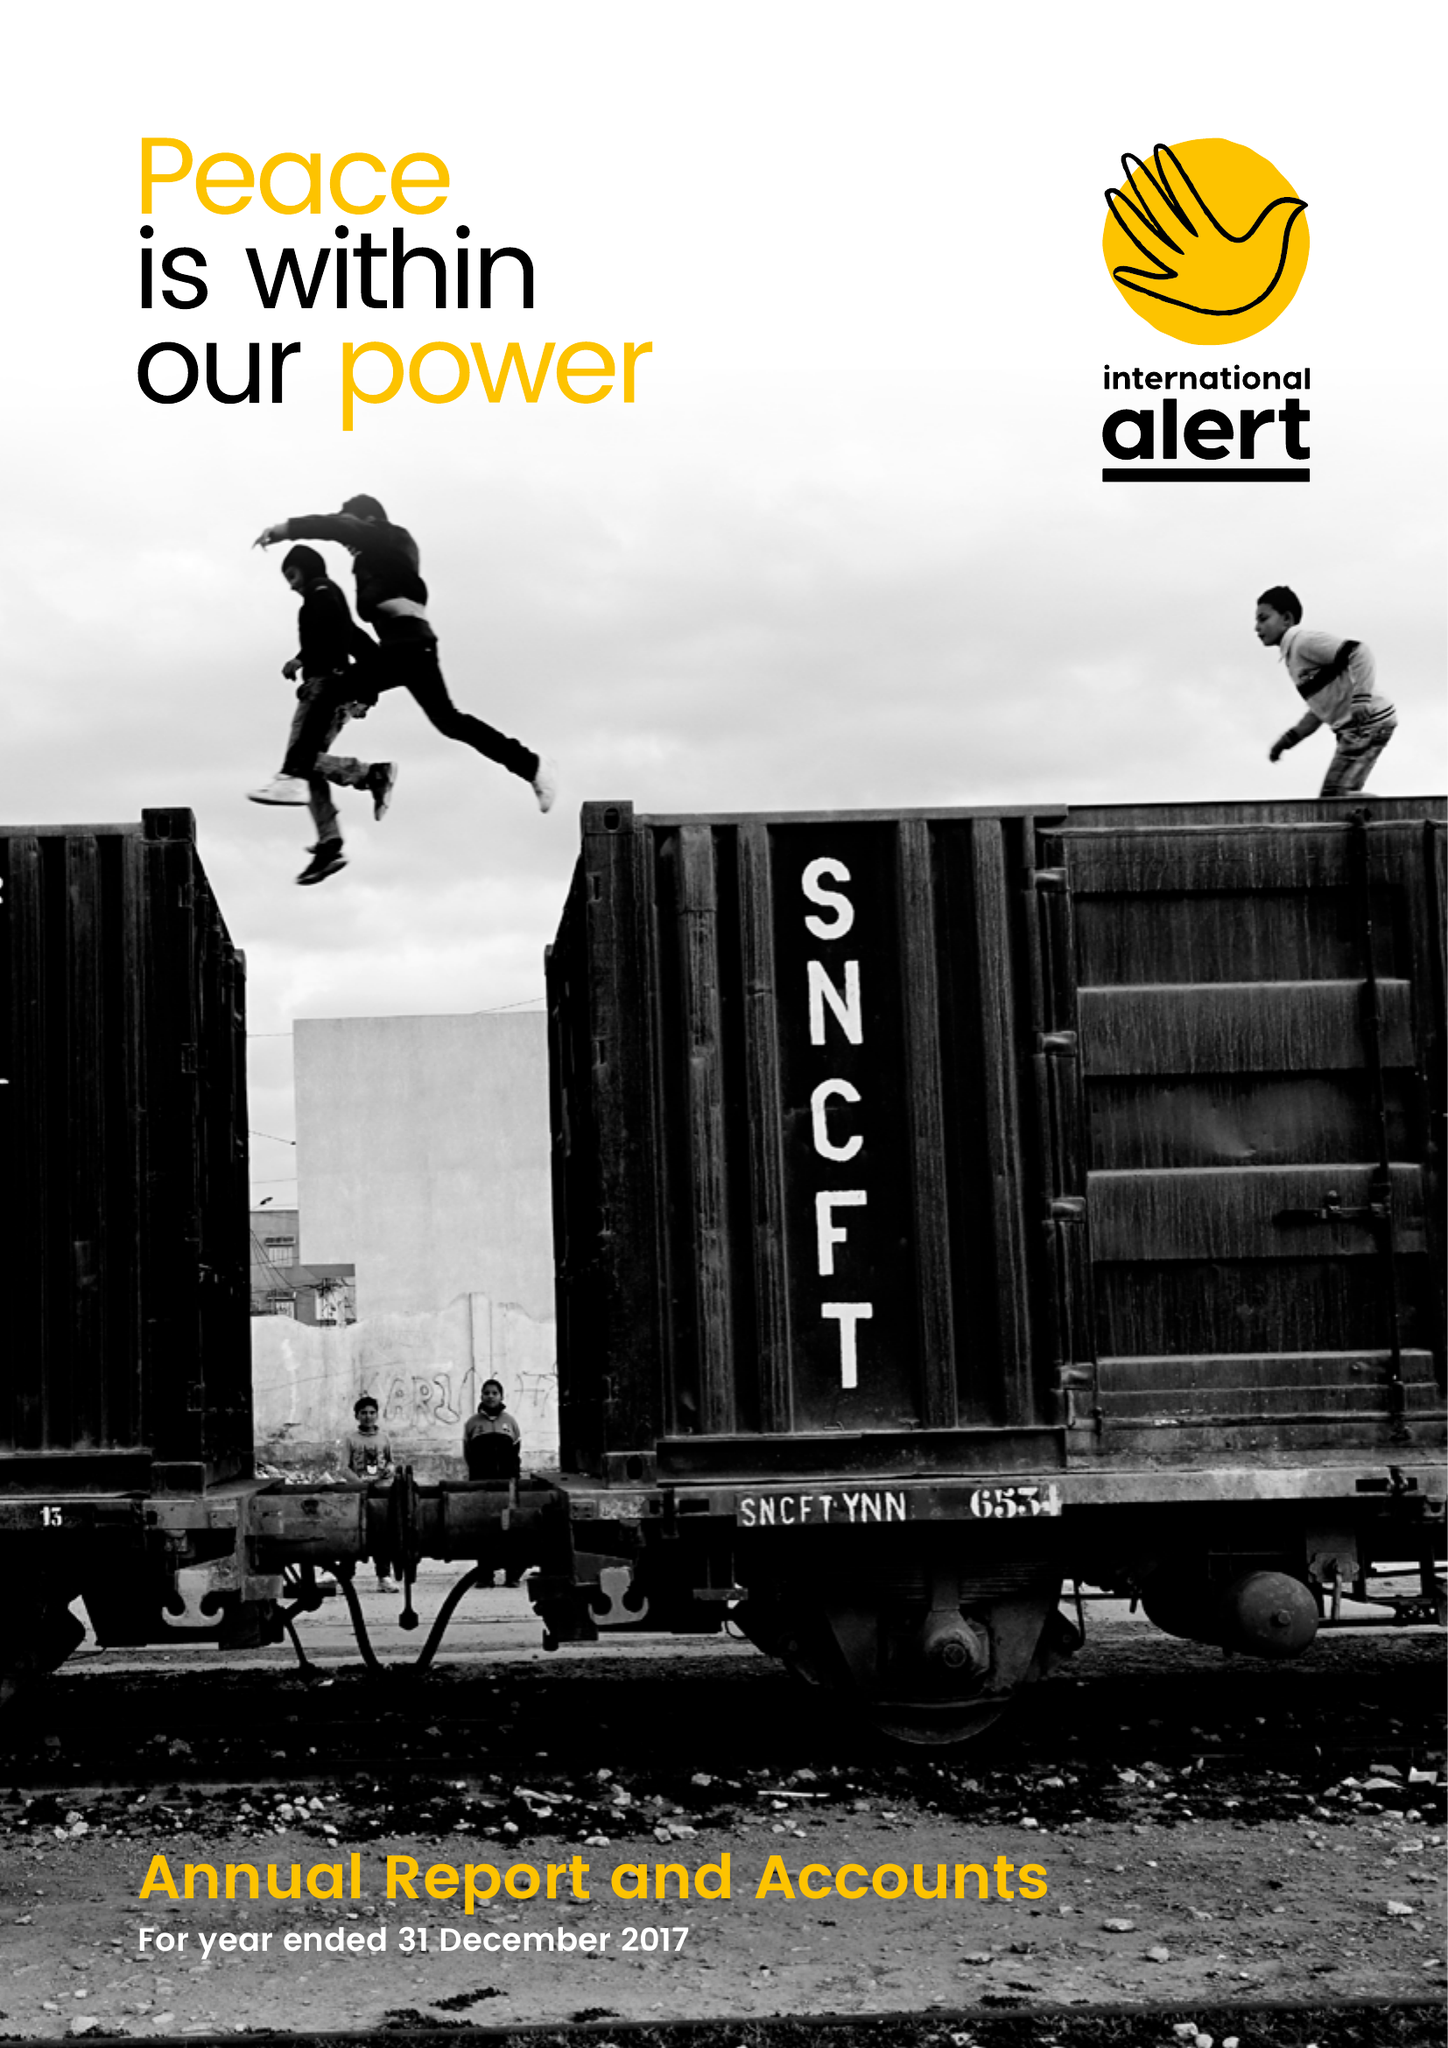What is the value for the address__post_town?
Answer the question using a single word or phrase. LONDON 